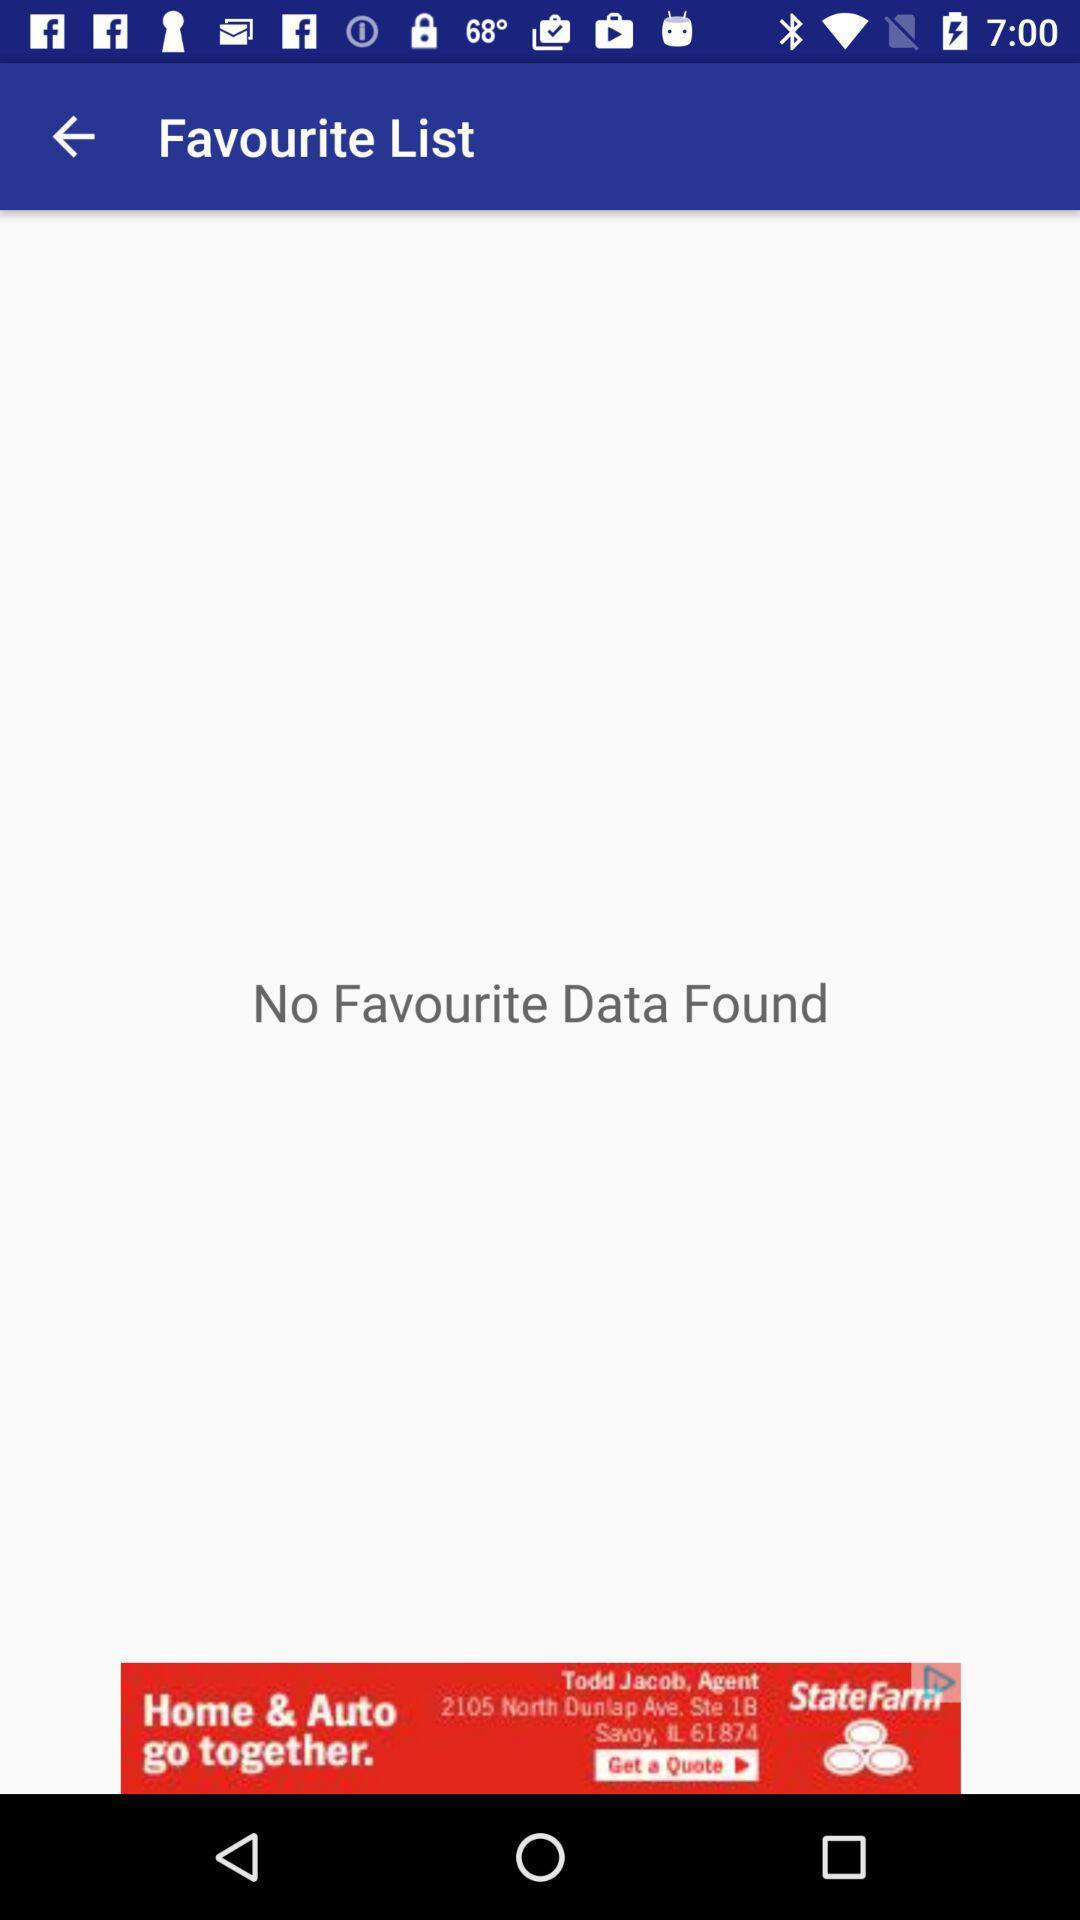Is there any favourite data? There is no favourite data. 